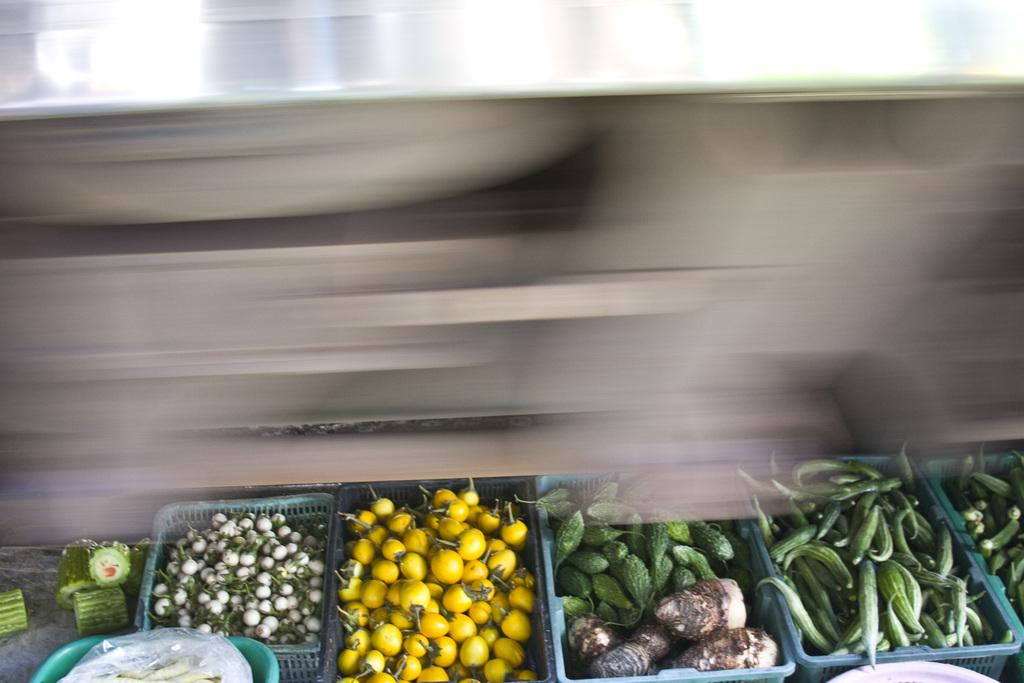What type of food items are visible in the image? There are vegetables in the image. How are the vegetables arranged or contained in the image? The vegetables are in baskets. Can you describe the background of the image? The background of the image is blurred. What type of cloud can be seen in the image? There is no cloud present in the image; it features vegetables in baskets with a blurred background. What time does the clock in the image show? There is no clock present in the image. 